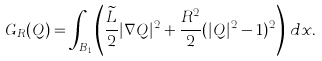Convert formula to latex. <formula><loc_0><loc_0><loc_500><loc_500>G _ { R } ( Q ) = \int _ { B _ { 1 } } \left ( \frac { \widetilde { L } } { 2 } | \nabla Q | ^ { 2 } + \frac { R ^ { 2 } } { 2 } ( | Q | ^ { 2 } - 1 ) ^ { 2 } \right ) \, d x .</formula> 